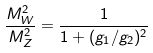Convert formula to latex. <formula><loc_0><loc_0><loc_500><loc_500>\frac { M _ { W } ^ { 2 } } { M _ { Z } ^ { 2 } } = \frac { 1 } { 1 + ( g _ { 1 } / g _ { 2 } ) ^ { 2 } }</formula> 